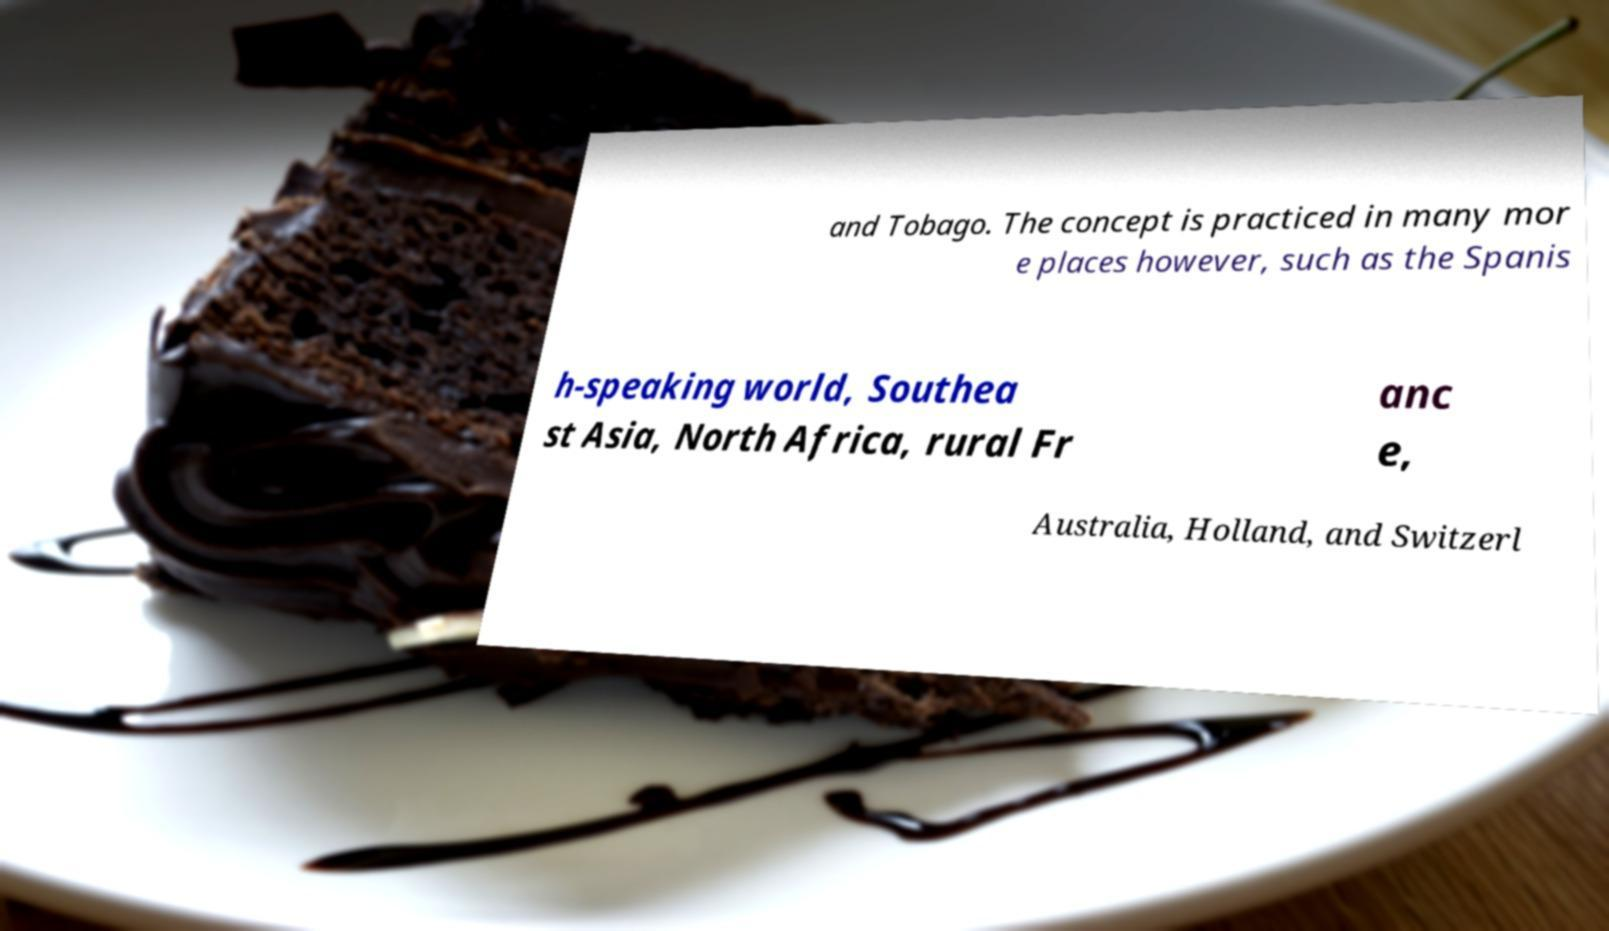There's text embedded in this image that I need extracted. Can you transcribe it verbatim? and Tobago. The concept is practiced in many mor e places however, such as the Spanis h-speaking world, Southea st Asia, North Africa, rural Fr anc e, Australia, Holland, and Switzerl 